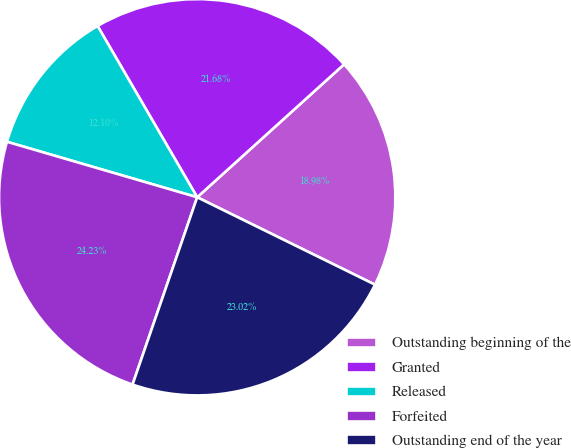Convert chart to OTSL. <chart><loc_0><loc_0><loc_500><loc_500><pie_chart><fcel>Outstanding beginning of the<fcel>Granted<fcel>Released<fcel>Forfeited<fcel>Outstanding end of the year<nl><fcel>18.98%<fcel>21.68%<fcel>12.1%<fcel>24.23%<fcel>23.02%<nl></chart> 